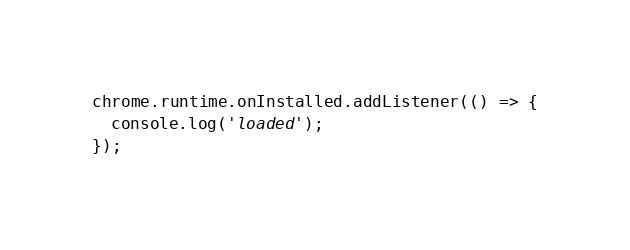<code> <loc_0><loc_0><loc_500><loc_500><_TypeScript_>chrome.runtime.onInstalled.addListener(() => {
  console.log('loaded');
});
</code> 